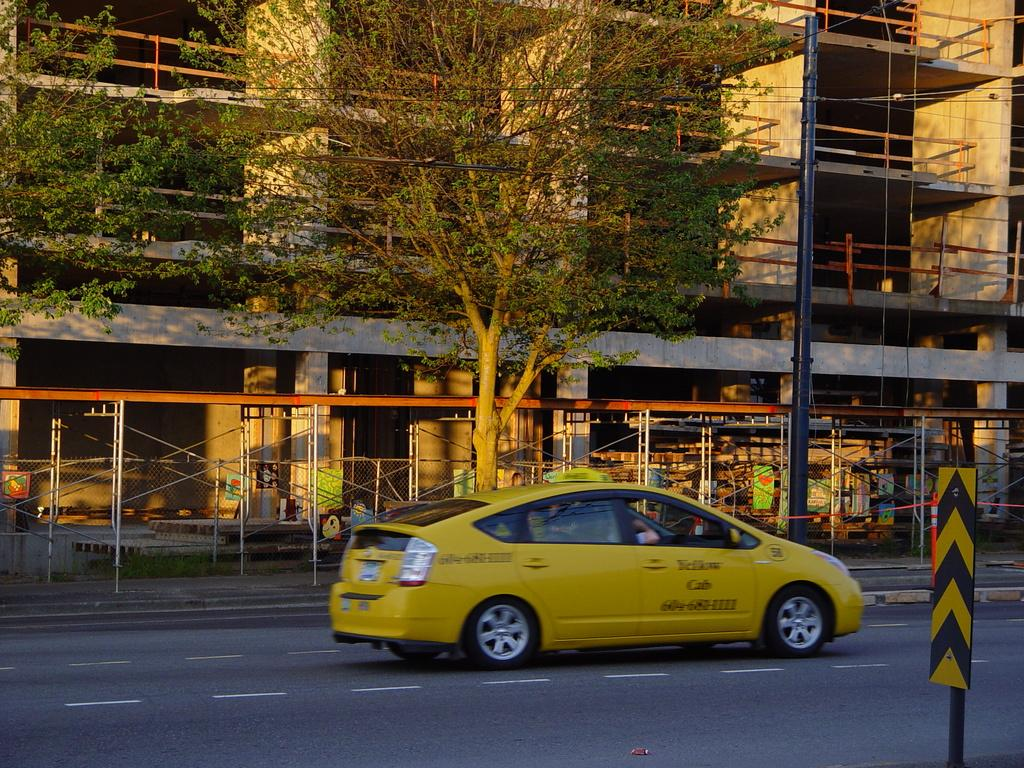<image>
Offer a succinct explanation of the picture presented. A taxi that says Yellow Cab on the side driving down a street. 